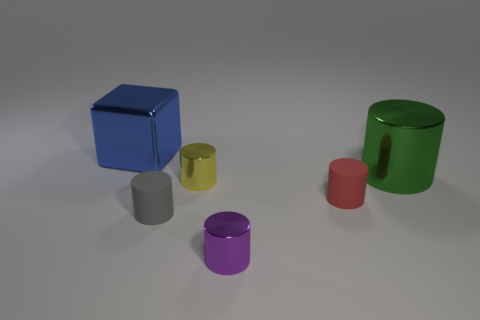Subtract all purple shiny cylinders. How many cylinders are left? 4 Subtract all green cylinders. How many cylinders are left? 4 Subtract all red cylinders. Subtract all green spheres. How many cylinders are left? 4 Add 2 big purple spheres. How many objects exist? 8 Subtract all blocks. How many objects are left? 5 Add 6 purple metal cubes. How many purple metal cubes exist? 6 Subtract 1 purple cylinders. How many objects are left? 5 Subtract all large gray matte cubes. Subtract all matte objects. How many objects are left? 4 Add 1 large metal blocks. How many large metal blocks are left? 2 